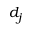<formula> <loc_0><loc_0><loc_500><loc_500>d _ { j }</formula> 